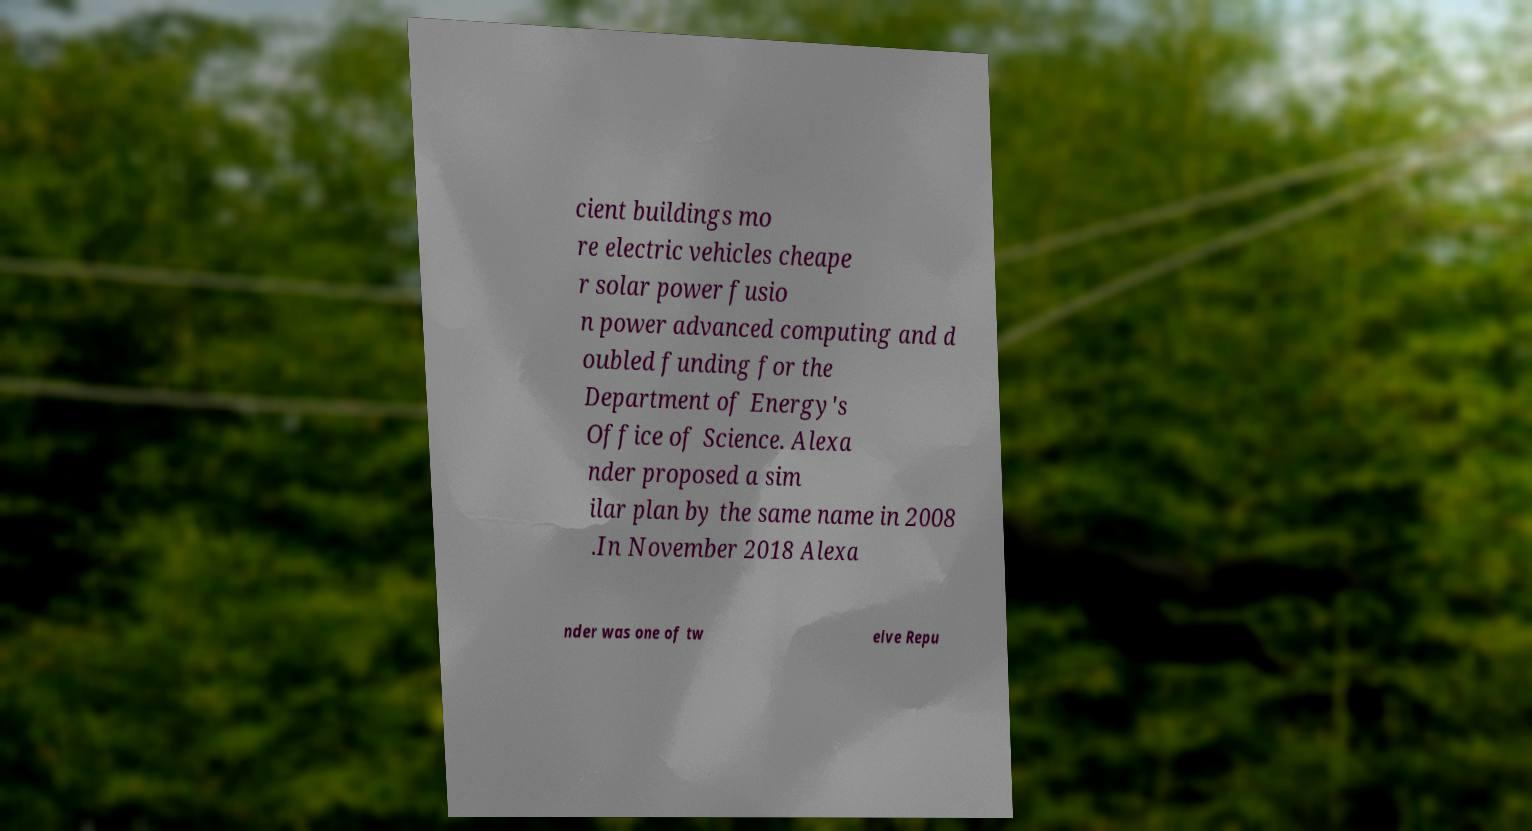I need the written content from this picture converted into text. Can you do that? cient buildings mo re electric vehicles cheape r solar power fusio n power advanced computing and d oubled funding for the Department of Energy's Office of Science. Alexa nder proposed a sim ilar plan by the same name in 2008 .In November 2018 Alexa nder was one of tw elve Repu 